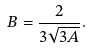Convert formula to latex. <formula><loc_0><loc_0><loc_500><loc_500>B = \frac { 2 } { 3 \sqrt { 3 A } } .</formula> 